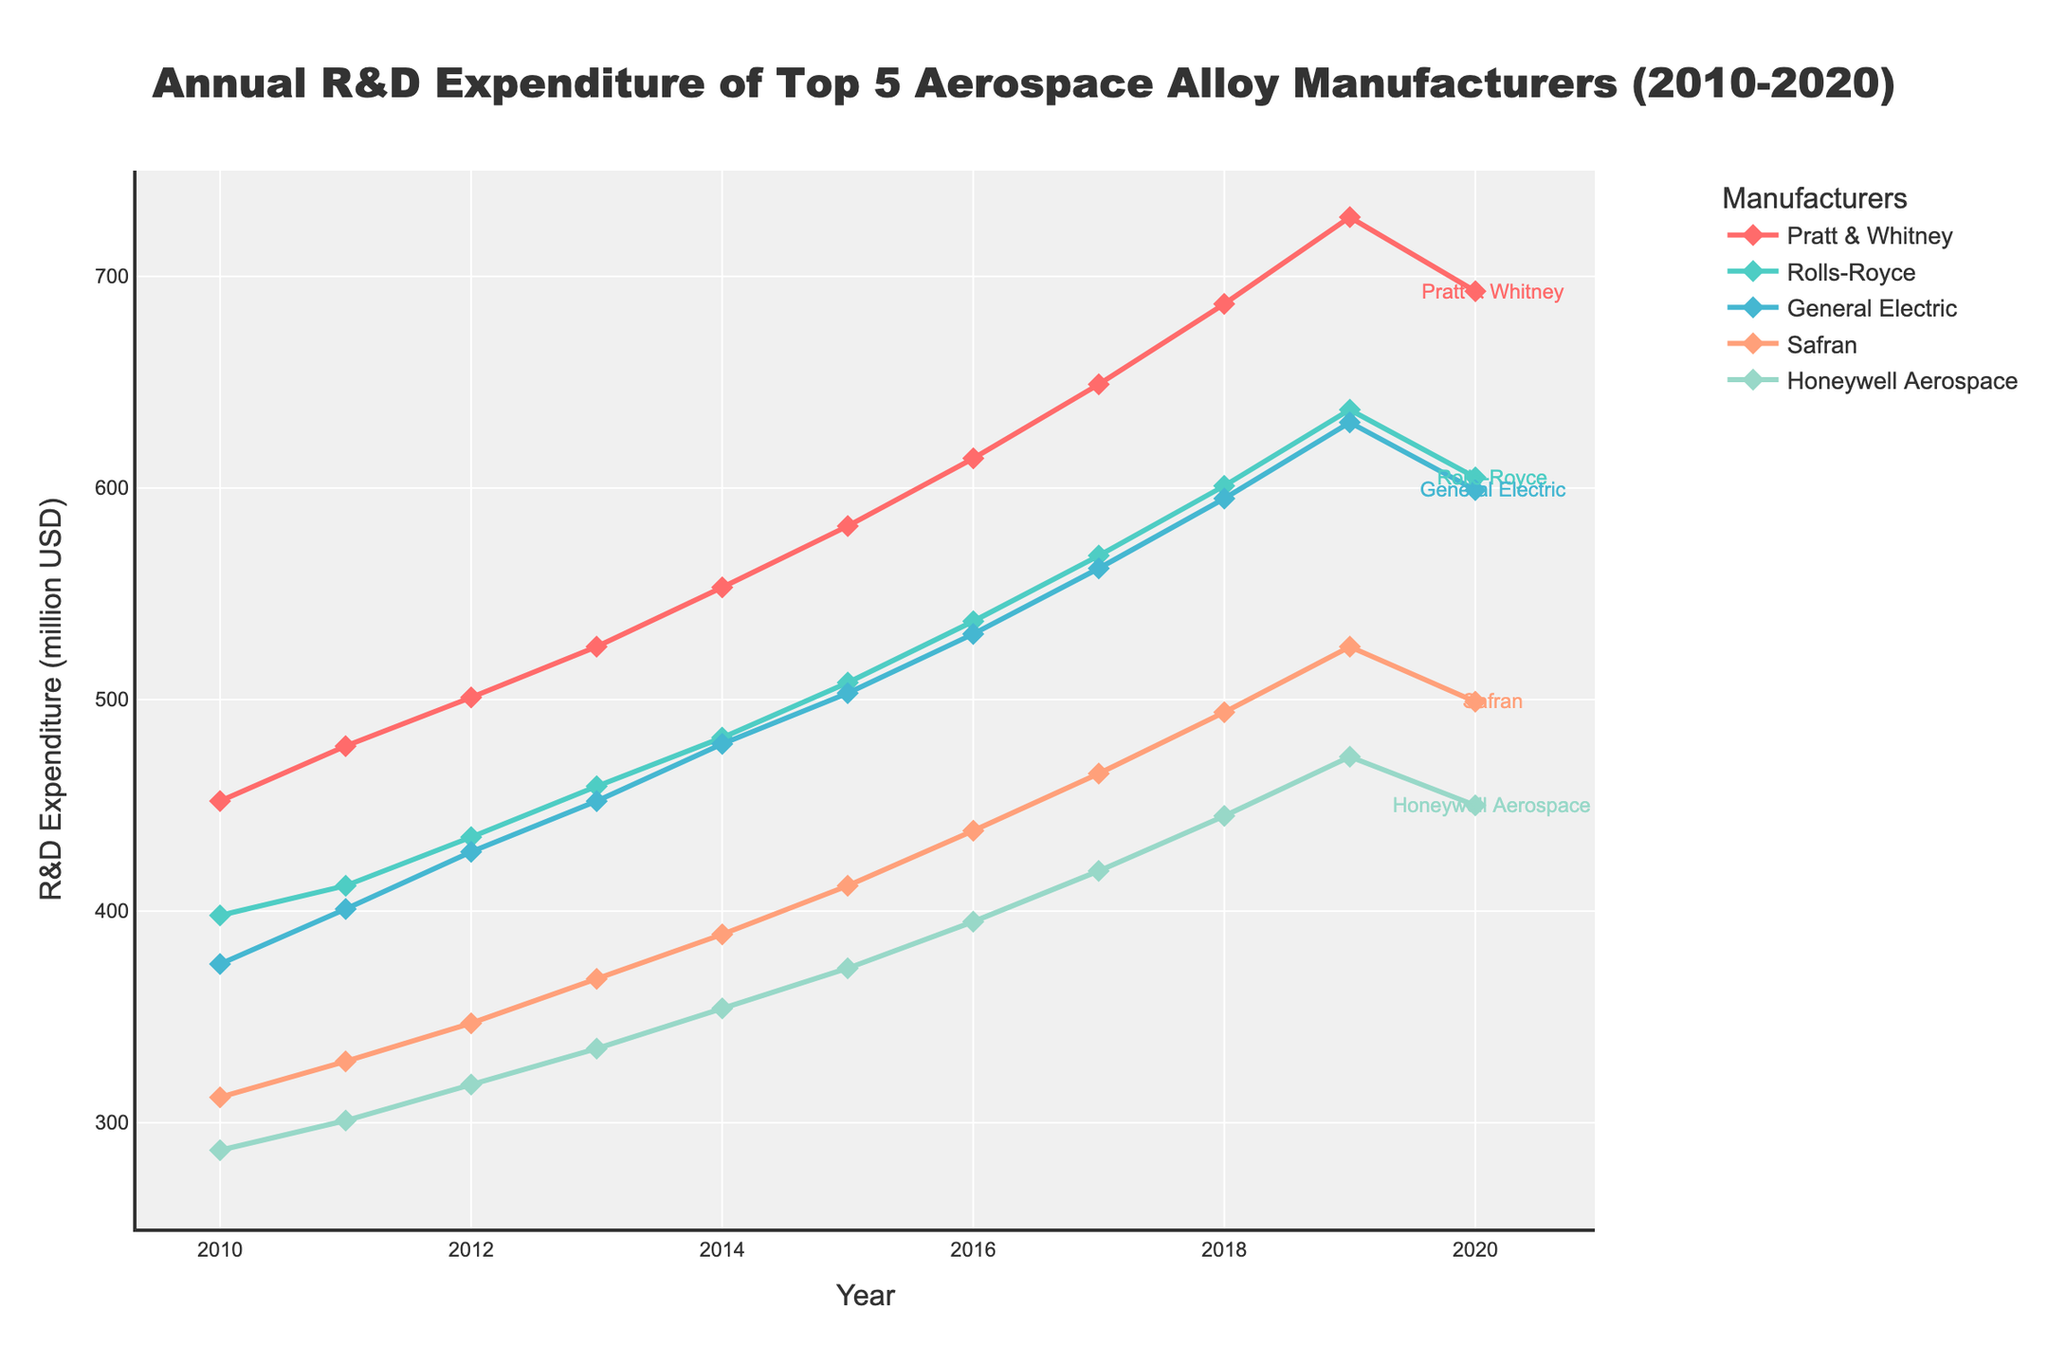what is the overall trend in R&D expenditure for General Electric from 2010 to 2020? From 2010 to 2019, General Electric's R&D expenditure shows a steady upward trend, increasing from 375 million USD in 2010 to 631 million USD in 2019. However, in 2020, there is a slight decrease to 599 million USD.
Answer: Steady increase till 2019, then a slight decrease in 2020 Which company had the highest R&D expenditure in 2020? By looking at the year 2020 data points, Pratt & Whitney had the highest R&D expenditure at 693 million USD.
Answer: Pratt & Whitney How much did Rolls-Royce's R&D expenditure increase from 2010 to 2020? Rolls-Royce's R&D expenditure in 2010 was 398 million USD and in 2020, it was 605 million USD. The increase is therefore 605 - 398 = 207 million USD.
Answer: 207 million USD Which two companies had the closest R&D expenditures in 2015? Examining the data for 2015, Rolls-Royce had an R&D expenditure of 508 million USD, and General Electric had an expenditure of 503 million USD. The difference between them is the smallest.
Answer: Rolls-Royce and General Electric What is the average annual increase in R&D expenditure for Safran between 2010 and 2019? Safran's R&D expenditure in 2010 was 312 million USD and in 2019, it was 525 million USD. The total increase over 9 years is 525 - 312 = 213 million USD. The average annual increase is 213 / 9 = 23.67 million USD.
Answer: 23.67 million USD Which company showed a decline in R&D expenditure from 2019 to 2020? Comparing the data for 2019 to 2020, both Pratt & Whitney and Rolls-Royce showed a decline in R&D expenditure. Pratt & Whitney decreased from 728 to 693 million USD, and Rolls-Royce decreased from 637 to 605 million USD.
Answer: Pratt & Whitney and Rolls-Royce What was the difference in R&D expenditure between Honeywell Aerospace and Safran in 2018? In 2018, Honeywell Aerospace's R&D expenditure was 445 million USD, and Safran's was 494 million USD. The difference is 494 - 445 = 49 million USD.
Answer: 49 million USD What is the total R&D expenditure of all companies combined in 2013? The combined R&D expenditure for all companies in 2013 is calculated as follows: 
452 (Pratt & Whitney) + 459 (Rolls-Royce) + 452 (General Electric) + 368 (Safran) + 335 (Honeywell Aerospace) = 2066 million USD.
Answer: 2066 million USD Did General Electric ever overtake any company in R&D expenditure? If yes, in which year? Yes, General Electric overtook Honeywell Aerospace in 2013. Before 2013, Honeywell Aerospace had higher expenditure, but in 2013, both companies had the same R&D expenditure of 452 million USD. After that year, General Electric’s expenditure was higher.
Answer: Yes, in 2013 How many companies had an R&D expenditure of above 500 million USD in 2016? In 2016, the companies with R&D expenditure above 500 million USD were Pratt & Whitney (614 million USD), Rolls-Royce (537 million USD), and General Electric (531 million USD).
Answer: Three companies 